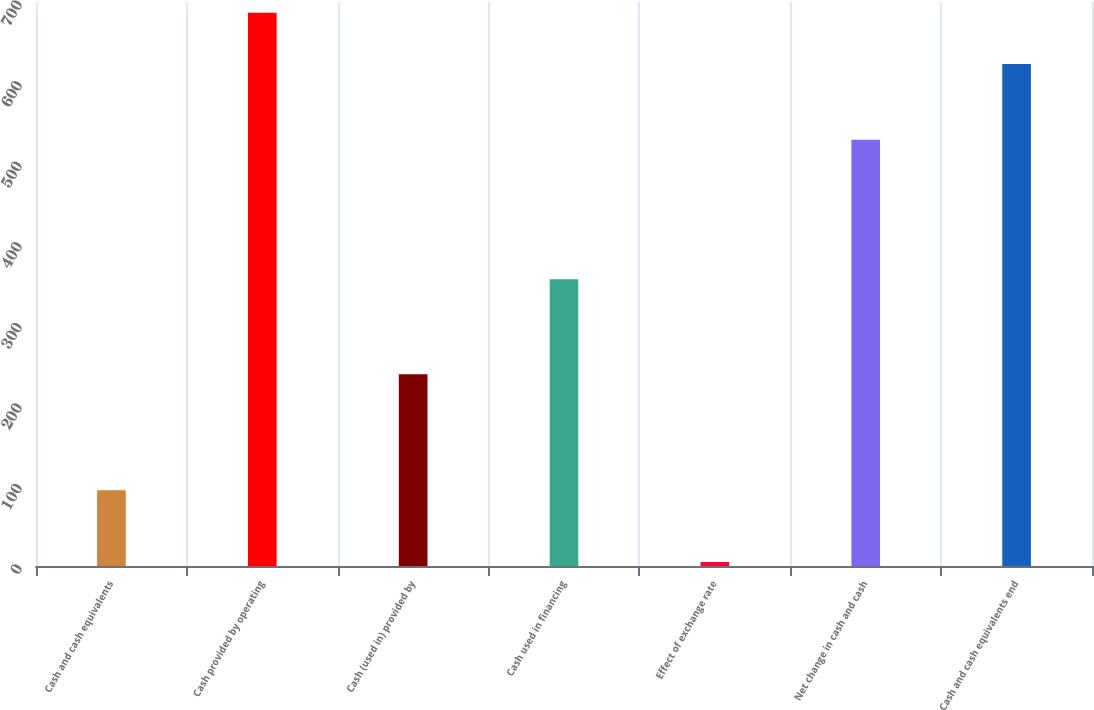Convert chart. <chart><loc_0><loc_0><loc_500><loc_500><bar_chart><fcel>Cash and cash equivalents<fcel>Cash provided by operating<fcel>Cash (used in) provided by<fcel>Cash used in financing<fcel>Effect of exchange rate<fcel>Net change in cash and cash<fcel>Cash and cash equivalents end<nl><fcel>94<fcel>686.7<fcel>238<fcel>356<fcel>5<fcel>529<fcel>623<nl></chart> 